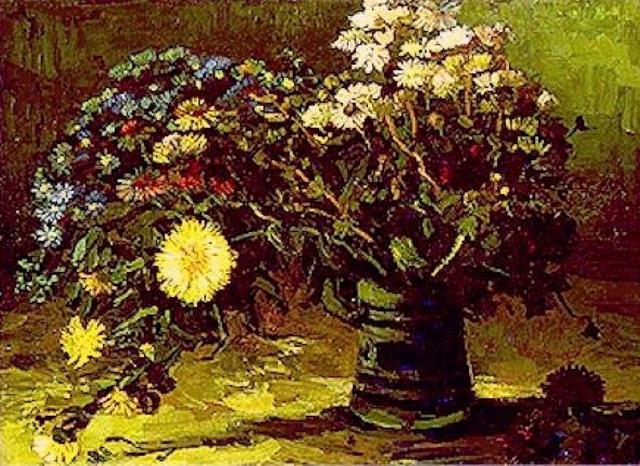What is the vase sitting on?
Quick response, please. Table. What is the color of the leaves?
Be succinct. Green. Is there any fruit in this photo?
Give a very brief answer. No. Who is the artist?
Give a very brief answer. Van gogh. What color is the vase?
Short answer required. Green. What is holding all the flowers together?
Be succinct. Vase. What colors are the flowers?
Write a very short answer. Blue yellow red green. 